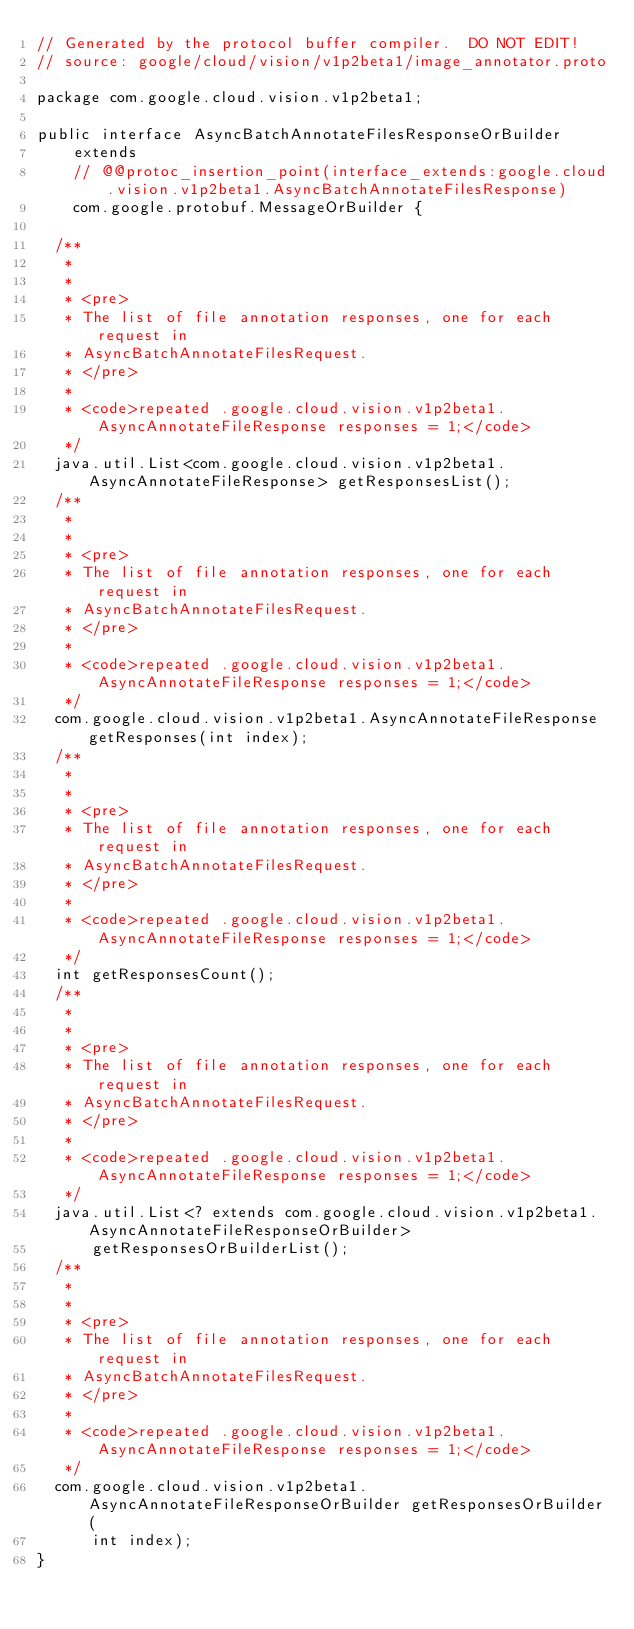<code> <loc_0><loc_0><loc_500><loc_500><_Java_>// Generated by the protocol buffer compiler.  DO NOT EDIT!
// source: google/cloud/vision/v1p2beta1/image_annotator.proto

package com.google.cloud.vision.v1p2beta1;

public interface AsyncBatchAnnotateFilesResponseOrBuilder
    extends
    // @@protoc_insertion_point(interface_extends:google.cloud.vision.v1p2beta1.AsyncBatchAnnotateFilesResponse)
    com.google.protobuf.MessageOrBuilder {

  /**
   *
   *
   * <pre>
   * The list of file annotation responses, one for each request in
   * AsyncBatchAnnotateFilesRequest.
   * </pre>
   *
   * <code>repeated .google.cloud.vision.v1p2beta1.AsyncAnnotateFileResponse responses = 1;</code>
   */
  java.util.List<com.google.cloud.vision.v1p2beta1.AsyncAnnotateFileResponse> getResponsesList();
  /**
   *
   *
   * <pre>
   * The list of file annotation responses, one for each request in
   * AsyncBatchAnnotateFilesRequest.
   * </pre>
   *
   * <code>repeated .google.cloud.vision.v1p2beta1.AsyncAnnotateFileResponse responses = 1;</code>
   */
  com.google.cloud.vision.v1p2beta1.AsyncAnnotateFileResponse getResponses(int index);
  /**
   *
   *
   * <pre>
   * The list of file annotation responses, one for each request in
   * AsyncBatchAnnotateFilesRequest.
   * </pre>
   *
   * <code>repeated .google.cloud.vision.v1p2beta1.AsyncAnnotateFileResponse responses = 1;</code>
   */
  int getResponsesCount();
  /**
   *
   *
   * <pre>
   * The list of file annotation responses, one for each request in
   * AsyncBatchAnnotateFilesRequest.
   * </pre>
   *
   * <code>repeated .google.cloud.vision.v1p2beta1.AsyncAnnotateFileResponse responses = 1;</code>
   */
  java.util.List<? extends com.google.cloud.vision.v1p2beta1.AsyncAnnotateFileResponseOrBuilder>
      getResponsesOrBuilderList();
  /**
   *
   *
   * <pre>
   * The list of file annotation responses, one for each request in
   * AsyncBatchAnnotateFilesRequest.
   * </pre>
   *
   * <code>repeated .google.cloud.vision.v1p2beta1.AsyncAnnotateFileResponse responses = 1;</code>
   */
  com.google.cloud.vision.v1p2beta1.AsyncAnnotateFileResponseOrBuilder getResponsesOrBuilder(
      int index);
}
</code> 